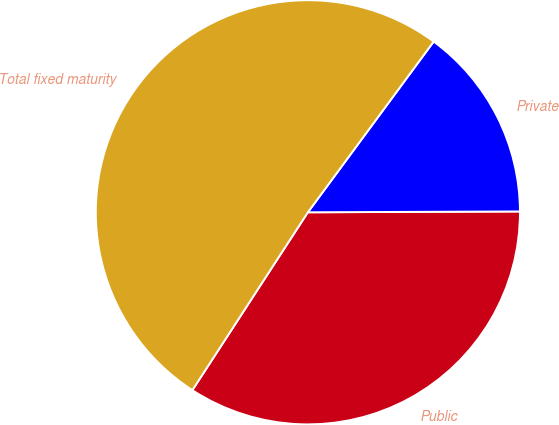<chart> <loc_0><loc_0><loc_500><loc_500><pie_chart><fcel>Public<fcel>Private<fcel>Total fixed maturity<nl><fcel>34.23%<fcel>14.83%<fcel>50.94%<nl></chart> 